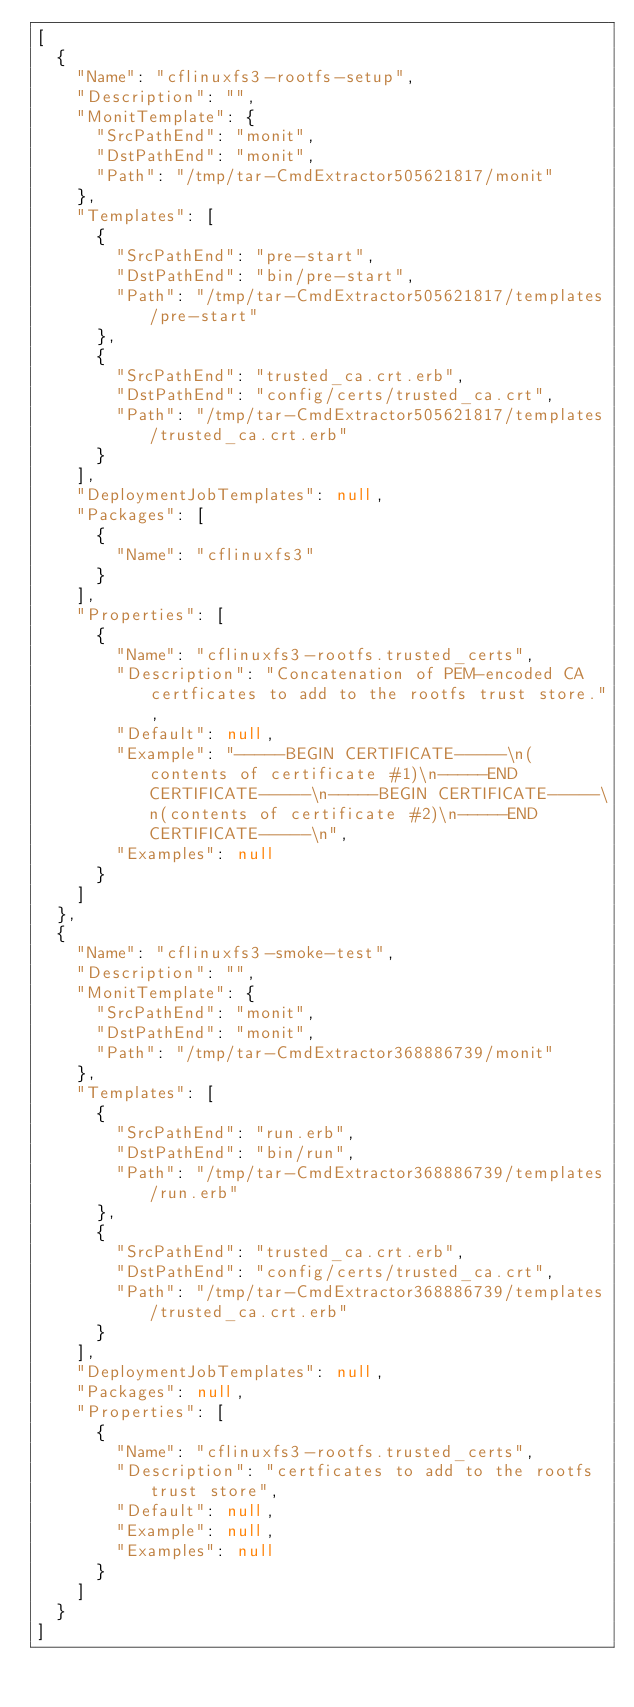Convert code to text. <code><loc_0><loc_0><loc_500><loc_500><_YAML_>[
  {
    "Name": "cflinuxfs3-rootfs-setup",
    "Description": "",
    "MonitTemplate": {
      "SrcPathEnd": "monit",
      "DstPathEnd": "monit",
      "Path": "/tmp/tar-CmdExtractor505621817/monit"
    },
    "Templates": [
      {
        "SrcPathEnd": "pre-start",
        "DstPathEnd": "bin/pre-start",
        "Path": "/tmp/tar-CmdExtractor505621817/templates/pre-start"
      },
      {
        "SrcPathEnd": "trusted_ca.crt.erb",
        "DstPathEnd": "config/certs/trusted_ca.crt",
        "Path": "/tmp/tar-CmdExtractor505621817/templates/trusted_ca.crt.erb"
      }
    ],
    "DeploymentJobTemplates": null,
    "Packages": [
      {
        "Name": "cflinuxfs3"
      }
    ],
    "Properties": [
      {
        "Name": "cflinuxfs3-rootfs.trusted_certs",
        "Description": "Concatenation of PEM-encoded CA certficates to add to the rootfs trust store.",
        "Default": null,
        "Example": "-----BEGIN CERTIFICATE-----\n(contents of certificate #1)\n-----END CERTIFICATE-----\n-----BEGIN CERTIFICATE-----\n(contents of certificate #2)\n-----END CERTIFICATE-----\n",
        "Examples": null
      }
    ]
  },
  {
    "Name": "cflinuxfs3-smoke-test",
    "Description": "",
    "MonitTemplate": {
      "SrcPathEnd": "monit",
      "DstPathEnd": "monit",
      "Path": "/tmp/tar-CmdExtractor368886739/monit"
    },
    "Templates": [
      {
        "SrcPathEnd": "run.erb",
        "DstPathEnd": "bin/run",
        "Path": "/tmp/tar-CmdExtractor368886739/templates/run.erb"
      },
      {
        "SrcPathEnd": "trusted_ca.crt.erb",
        "DstPathEnd": "config/certs/trusted_ca.crt",
        "Path": "/tmp/tar-CmdExtractor368886739/templates/trusted_ca.crt.erb"
      }
    ],
    "DeploymentJobTemplates": null,
    "Packages": null,
    "Properties": [
      {
        "Name": "cflinuxfs3-rootfs.trusted_certs",
        "Description": "certficates to add to the rootfs trust store",
        "Default": null,
        "Example": null,
        "Examples": null
      }
    ]
  }
]</code> 